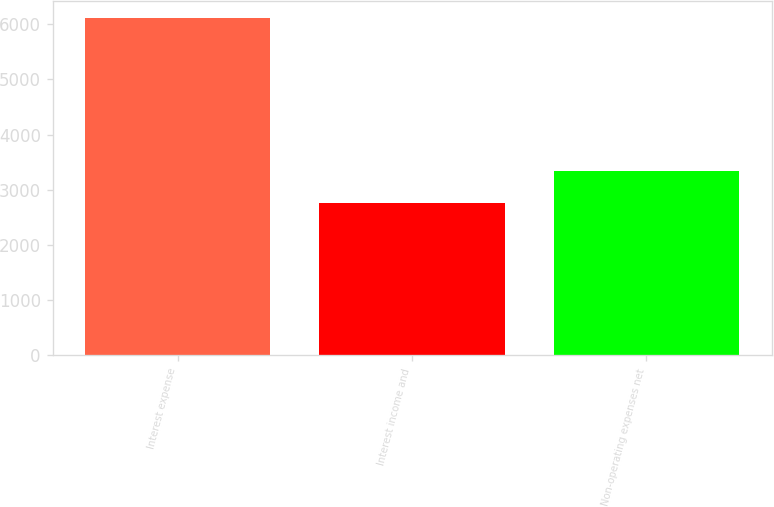Convert chart to OTSL. <chart><loc_0><loc_0><loc_500><loc_500><bar_chart><fcel>Interest expense<fcel>Interest income and<fcel>Non-operating expenses net<nl><fcel>6109<fcel>2768<fcel>3341<nl></chart> 